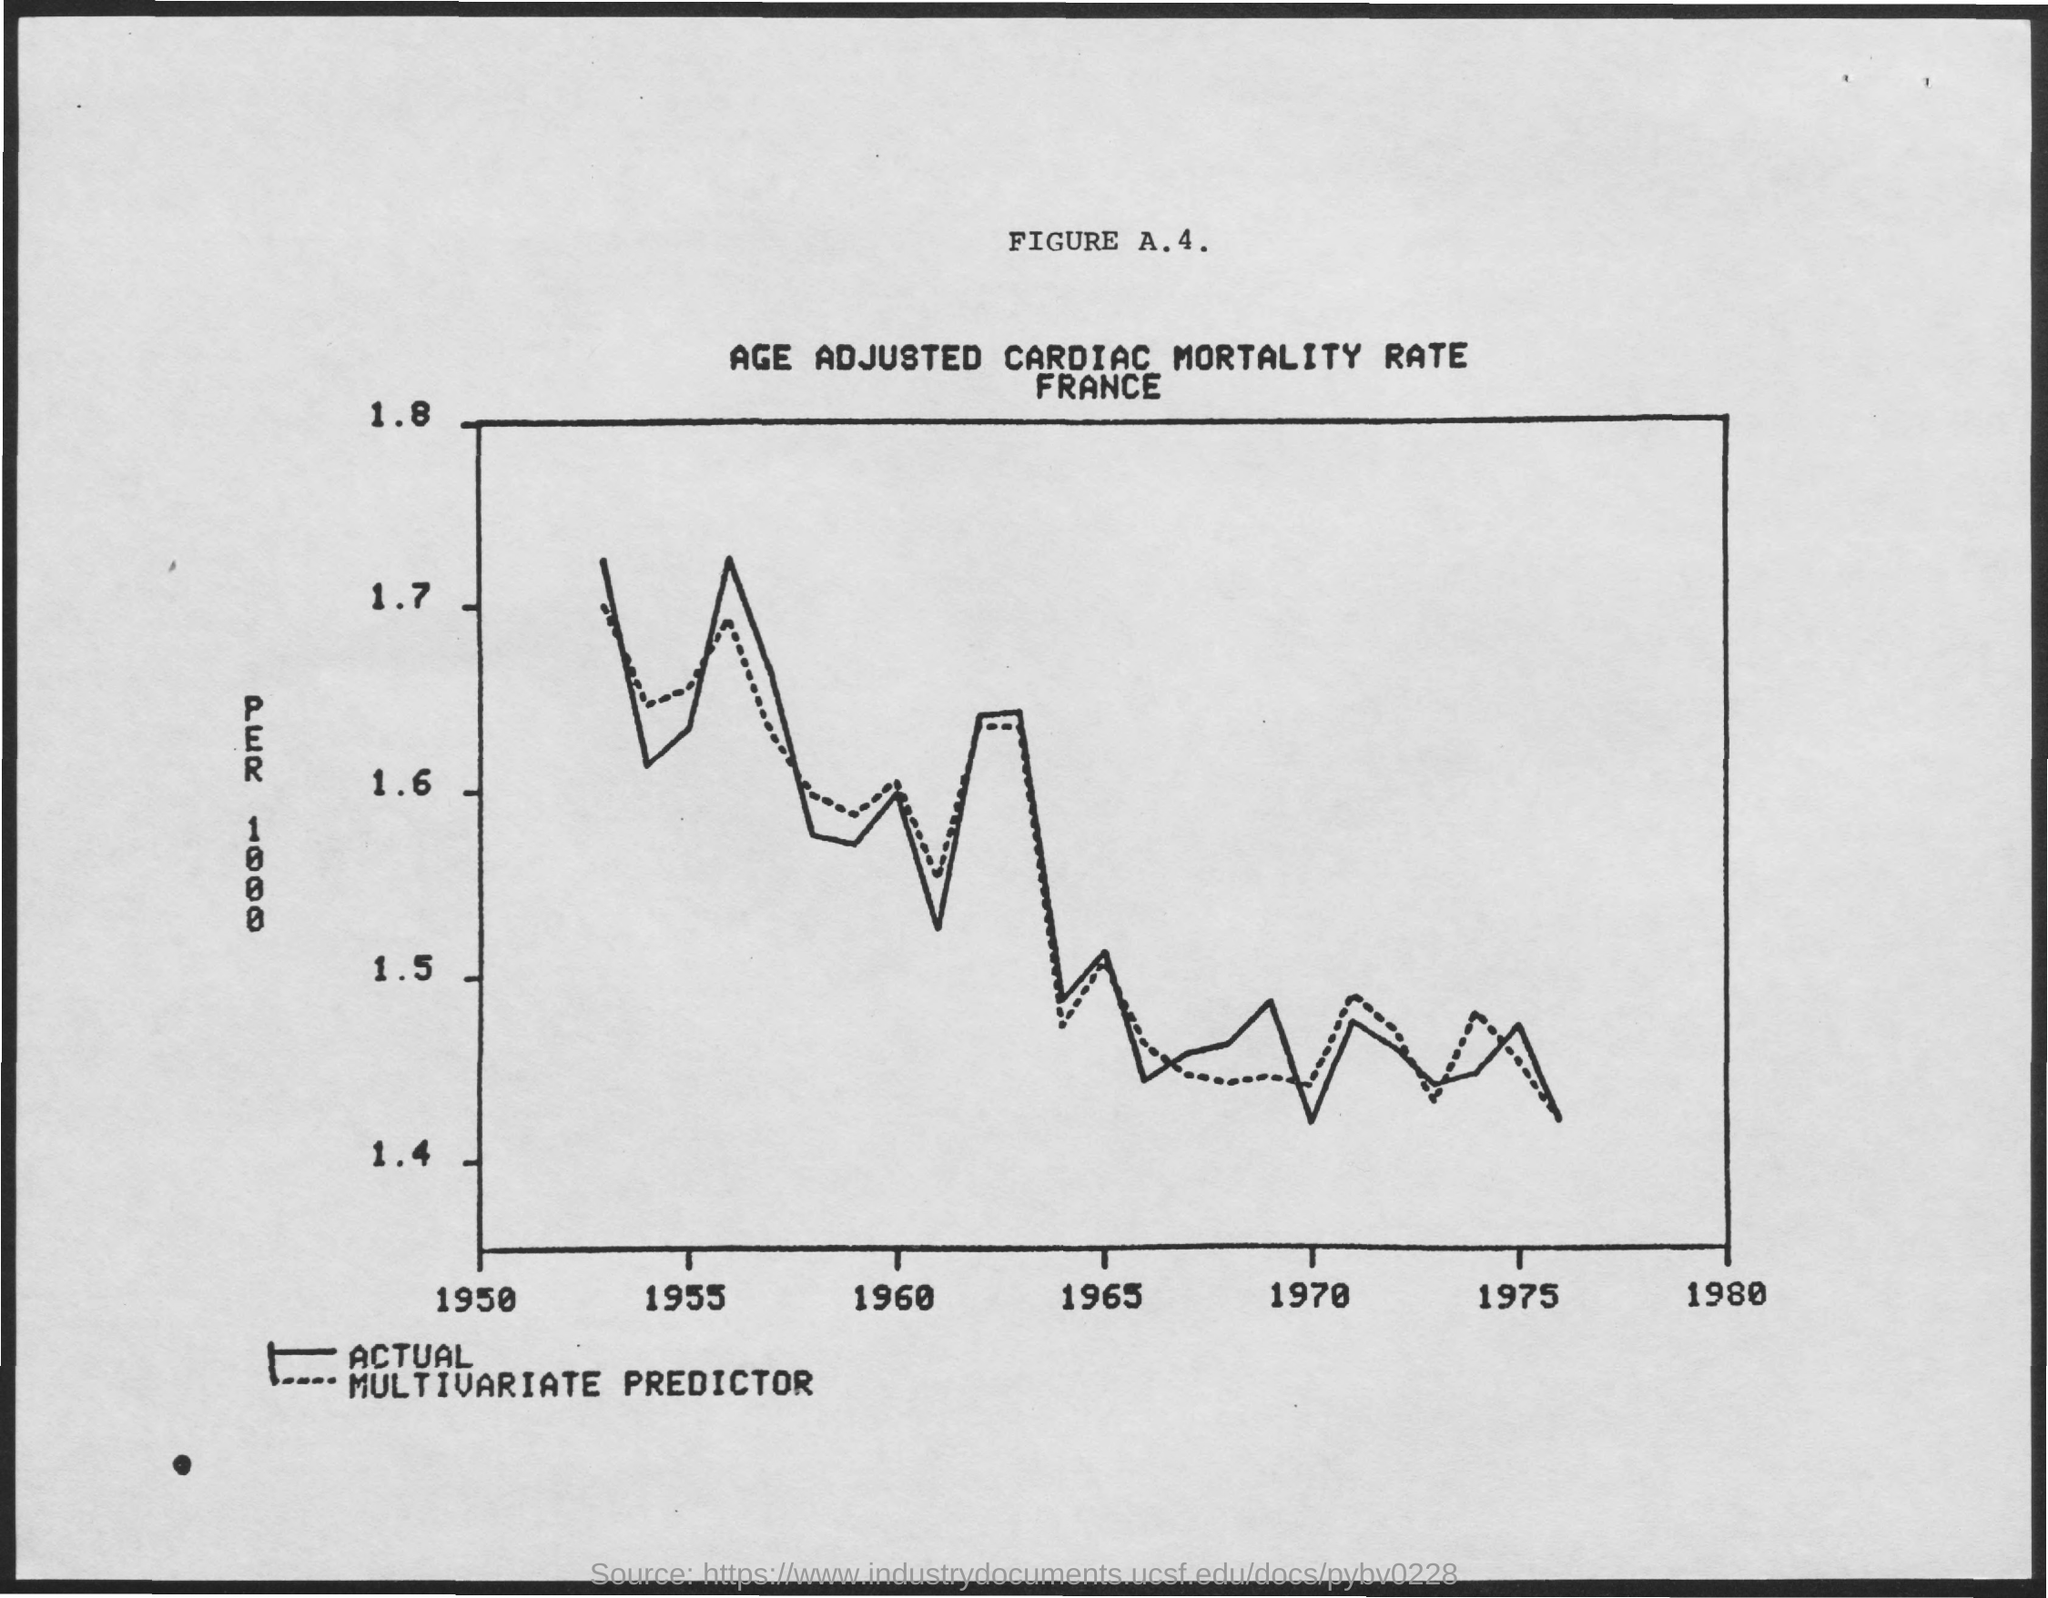Mention a couple of crucial points in this snapshot. The title of Figure A.4 is "Age-Adjusted Cardiac Mortality Rate. 